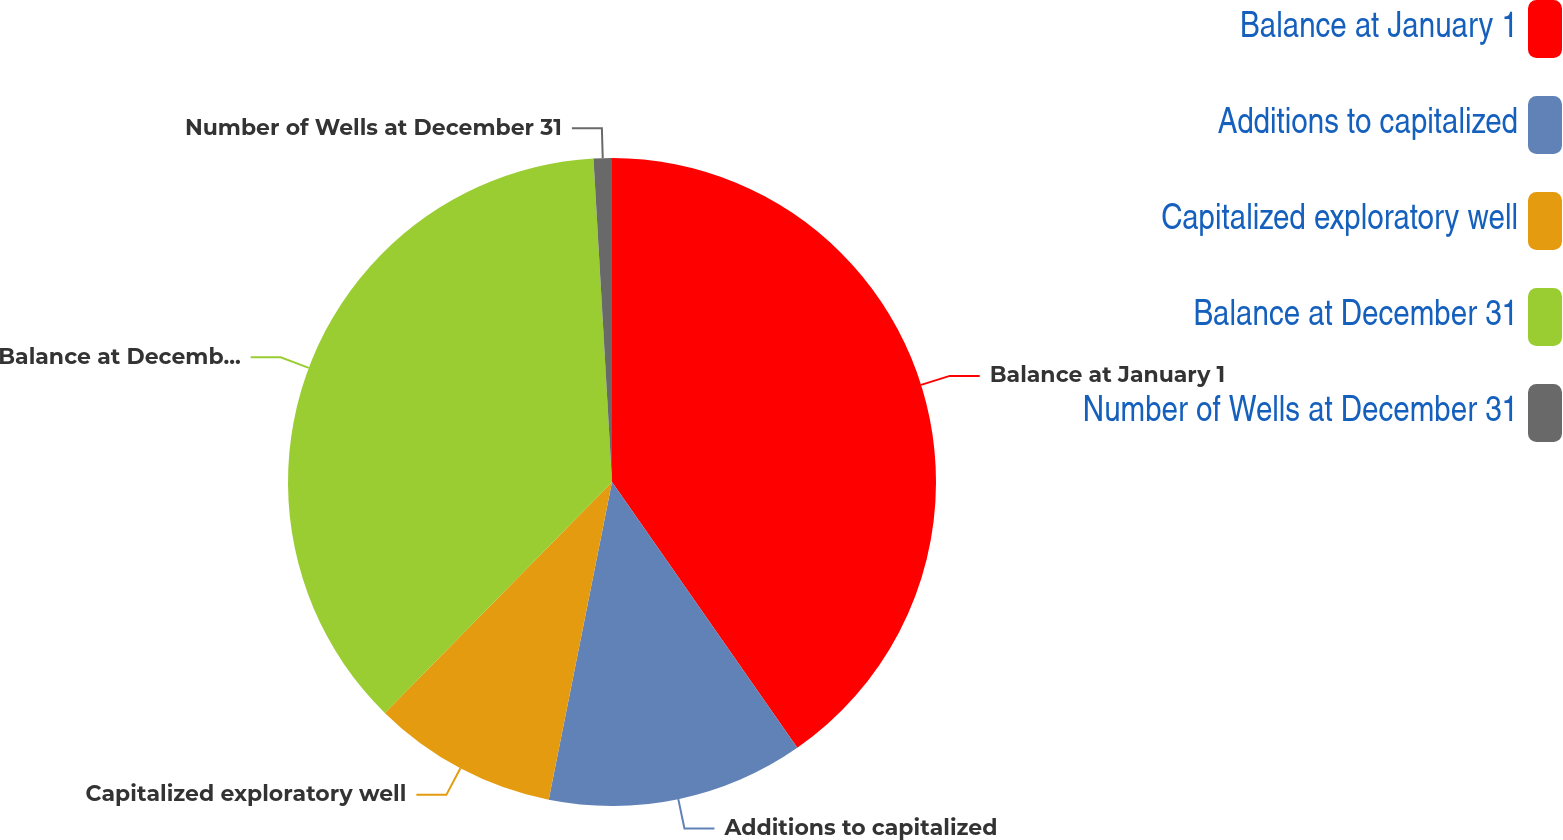<chart> <loc_0><loc_0><loc_500><loc_500><pie_chart><fcel>Balance at January 1<fcel>Additions to capitalized<fcel>Capitalized exploratory well<fcel>Balance at December 31<fcel>Number of Wells at December 31<nl><fcel>40.31%<fcel>12.82%<fcel>9.24%<fcel>36.72%<fcel>0.91%<nl></chart> 